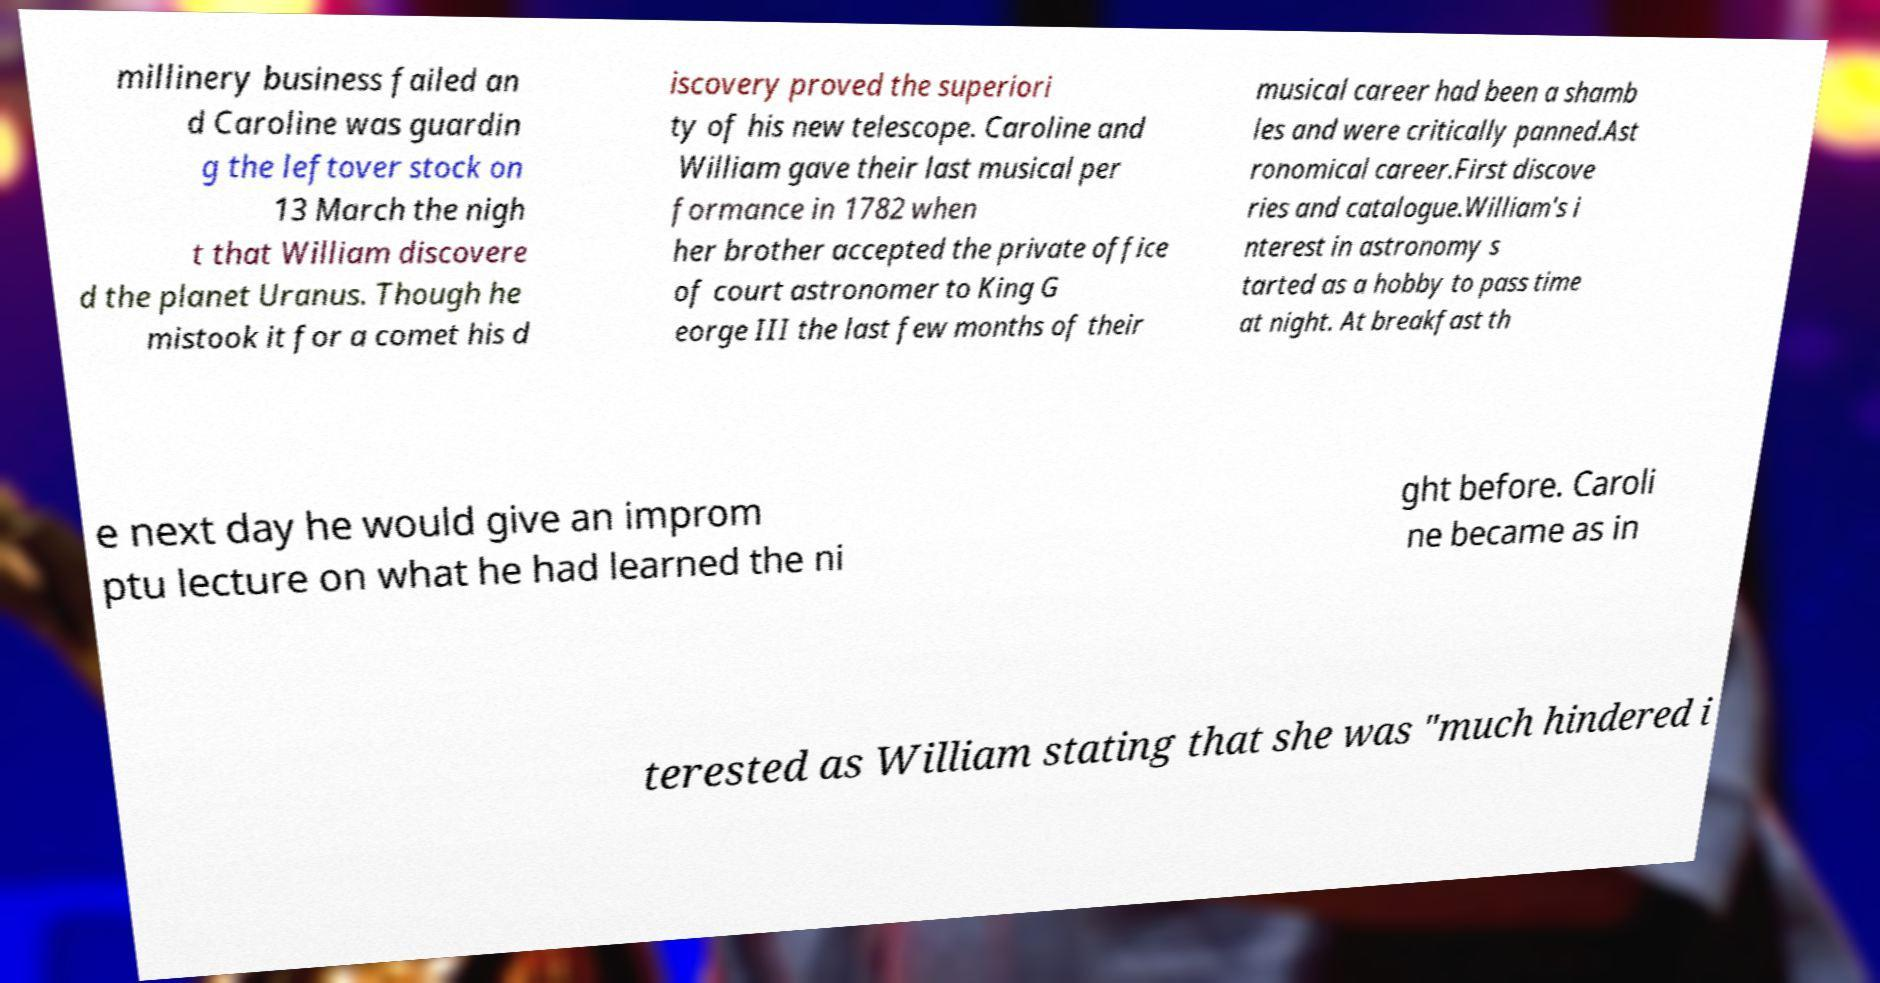For documentation purposes, I need the text within this image transcribed. Could you provide that? millinery business failed an d Caroline was guardin g the leftover stock on 13 March the nigh t that William discovere d the planet Uranus. Though he mistook it for a comet his d iscovery proved the superiori ty of his new telescope. Caroline and William gave their last musical per formance in 1782 when her brother accepted the private office of court astronomer to King G eorge III the last few months of their musical career had been a shamb les and were critically panned.Ast ronomical career.First discove ries and catalogue.William's i nterest in astronomy s tarted as a hobby to pass time at night. At breakfast th e next day he would give an improm ptu lecture on what he had learned the ni ght before. Caroli ne became as in terested as William stating that she was "much hindered i 